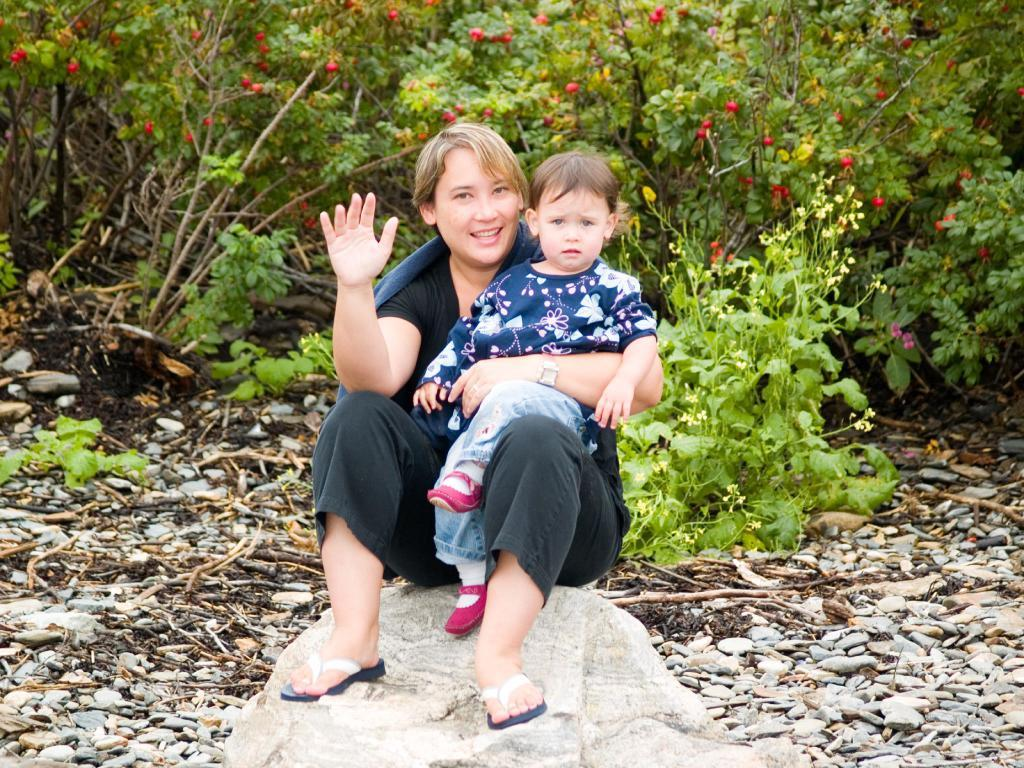What is the woman in the image doing? The woman is sitting on a rock in the image. Is there anyone else with the woman in the image? Yes, the woman is carrying a child. What type of objects can be seen on the ground in the image? Stones and dried branches are visible in the image. What kind of vegetation is present in the image? There is a group of plants with fruits and flowers in the image. What type of jeans is the woman wearing in the image? There is no information about the woman's clothing in the image, so we cannot determine if she is wearing jeans or any other type of clothing. 